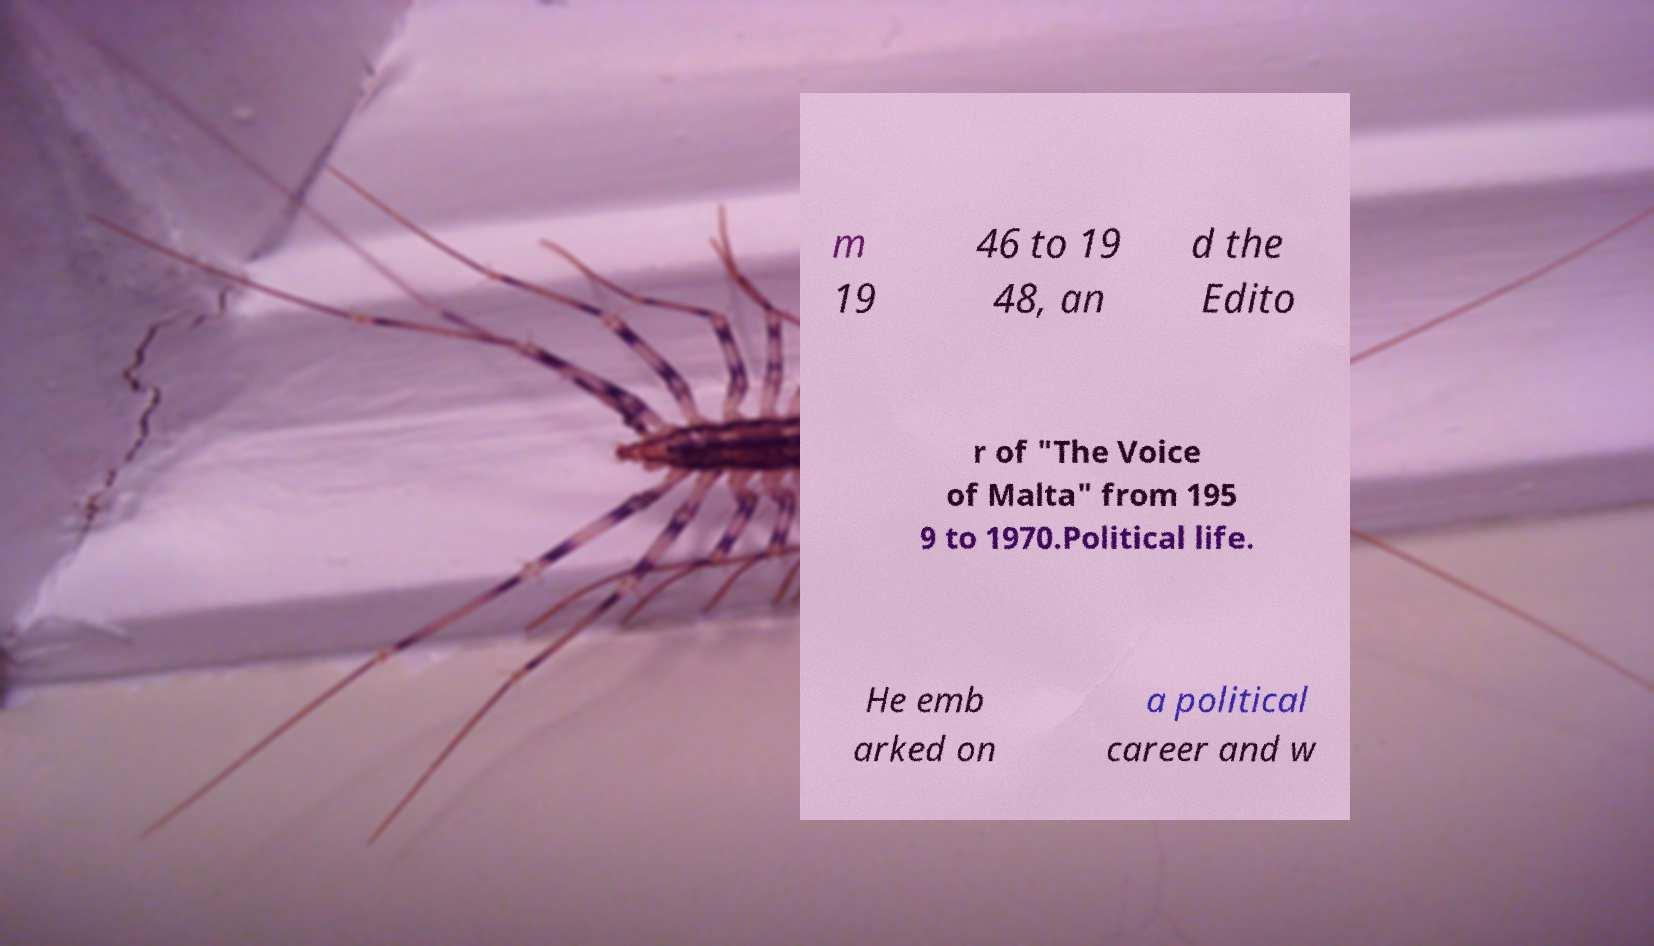Could you extract and type out the text from this image? m 19 46 to 19 48, an d the Edito r of "The Voice of Malta" from 195 9 to 1970.Political life. He emb arked on a political career and w 